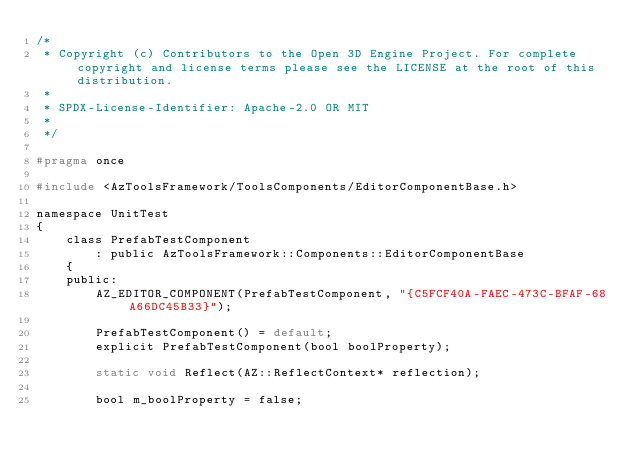<code> <loc_0><loc_0><loc_500><loc_500><_C_>/*
 * Copyright (c) Contributors to the Open 3D Engine Project. For complete copyright and license terms please see the LICENSE at the root of this distribution.
 * 
 * SPDX-License-Identifier: Apache-2.0 OR MIT
 *
 */

#pragma once

#include <AzToolsFramework/ToolsComponents/EditorComponentBase.h>

namespace UnitTest
{
    class PrefabTestComponent
        : public AzToolsFramework::Components::EditorComponentBase
    {
    public:
        AZ_EDITOR_COMPONENT(PrefabTestComponent, "{C5FCF40A-FAEC-473C-BFAF-68A66DC45B33}");

        PrefabTestComponent() = default;
        explicit PrefabTestComponent(bool boolProperty);

        static void Reflect(AZ::ReflectContext* reflection);

        bool m_boolProperty = false;</code> 